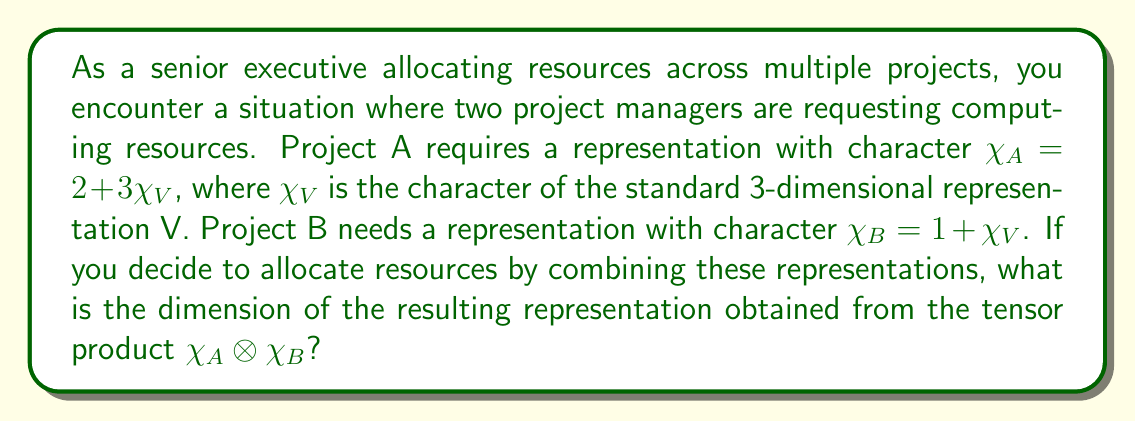Show me your answer to this math problem. Let's approach this step-by-step:

1) First, we need to calculate the tensor product $\chi_A \otimes \chi_B$:

   $\chi_A \otimes \chi_B = (2 + 3\chi_{V}) \otimes (1 + \chi_{V})$

2) Expanding this product:

   $\chi_A \otimes \chi_B = 2(1 + \chi_{V}) + 3\chi_{V}(1 + \chi_{V})$
                          $= 2 + 2\chi_{V} + 3\chi_{V} + 3\chi_{V} \otimes \chi_{V}$
                          $= 2 + 5\chi_{V} + 3(\chi_{V} \otimes \chi_{V})$

3) We know that $\chi_{V}$ is the character of the standard 3-dimensional representation. So, $\chi_{V}(1) = 3$.

4) For $\chi_{V} \otimes \chi_{V}$, we can use the formula for the tensor product of the standard representation with itself:

   $\chi_{V} \otimes \chi_{V} = \chi_{S^2V} + \chi_{\Lambda^2V} + \chi_1$

   Where $S^2V$ is the symmetric square, $\Lambda^2V$ is the exterior square, and $\chi_1$ is the trivial representation.

5) For a 3-dimensional V:
   - $dim(S^2V) = \frac{3(3+1)}{2} = 6$
   - $dim(\Lambda^2V) = \binom{3}{2} = 3$
   - $dim(\chi_1) = 1$

6) Therefore, $\chi_{V} \otimes \chi_{V} = 6 + 3 + 1 = 10$

7) Substituting back into our original expression:

   $\chi_A \otimes \chi_B = 2 + 5\chi_{V} + 3(10) = 2 + 5(3) + 30 = 47$

8) The dimension of a representation is the value of its character at the identity element. So, the dimension of the resulting representation is 47.
Answer: 47 